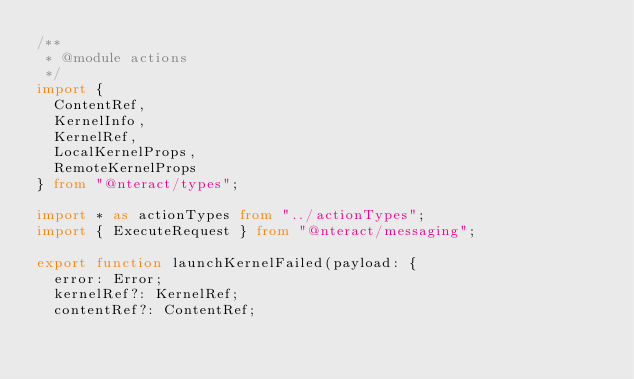<code> <loc_0><loc_0><loc_500><loc_500><_TypeScript_>/**
 * @module actions
 */
import {
  ContentRef,
  KernelInfo,
  KernelRef,
  LocalKernelProps,
  RemoteKernelProps
} from "@nteract/types";

import * as actionTypes from "../actionTypes";
import { ExecuteRequest } from "@nteract/messaging";

export function launchKernelFailed(payload: {
  error: Error;
  kernelRef?: KernelRef;
  contentRef?: ContentRef;</code> 